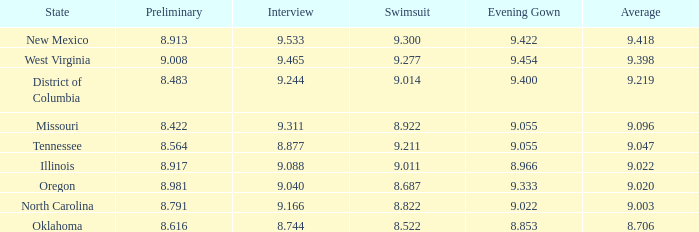Name the preliminary for north carolina 8.791. Write the full table. {'header': ['State', 'Preliminary', 'Interview', 'Swimsuit', 'Evening Gown', 'Average'], 'rows': [['New Mexico', '8.913', '9.533', '9.300', '9.422', '9.418'], ['West Virginia', '9.008', '9.465', '9.277', '9.454', '9.398'], ['District of Columbia', '8.483', '9.244', '9.014', '9.400', '9.219'], ['Missouri', '8.422', '9.311', '8.922', '9.055', '9.096'], ['Tennessee', '8.564', '8.877', '9.211', '9.055', '9.047'], ['Illinois', '8.917', '9.088', '9.011', '8.966', '9.022'], ['Oregon', '8.981', '9.040', '8.687', '9.333', '9.020'], ['North Carolina', '8.791', '9.166', '8.822', '9.022', '9.003'], ['Oklahoma', '8.616', '8.744', '8.522', '8.853', '8.706']]} 